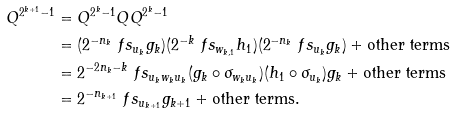Convert formula to latex. <formula><loc_0><loc_0><loc_500><loc_500>Q ^ { 2 ^ { k + 1 } - 1 } & = Q ^ { 2 ^ { k } - 1 } Q Q ^ { 2 ^ { k } - 1 } \\ & = ( 2 ^ { - n _ { k } } \ f s _ { u _ { k } } g _ { k } ) ( 2 ^ { - k } \ f s _ { w _ { k , 1 } } h _ { 1 } ) ( 2 ^ { - n _ { k } } \ f s _ { u _ { k } } g _ { k } ) + \text {other terms} \\ & = 2 ^ { - 2 n _ { k } - k } \ f s _ { u _ { k } w _ { k } u _ { k } } ( g _ { k } \circ \sigma _ { w _ { k } u _ { k } } ) ( h _ { 1 } \circ \sigma _ { u _ { k } } ) g _ { k } + \text {other terms} \\ & = 2 ^ { - n _ { k + 1 } } \ f s _ { u _ { k + 1 } } g _ { k + 1 } + \text {other terms} .</formula> 